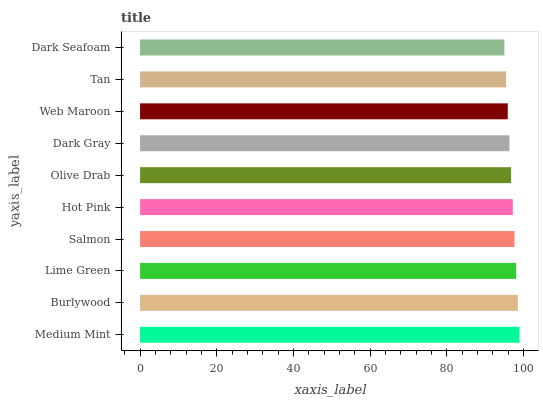Is Dark Seafoam the minimum?
Answer yes or no. Yes. Is Medium Mint the maximum?
Answer yes or no. Yes. Is Burlywood the minimum?
Answer yes or no. No. Is Burlywood the maximum?
Answer yes or no. No. Is Medium Mint greater than Burlywood?
Answer yes or no. Yes. Is Burlywood less than Medium Mint?
Answer yes or no. Yes. Is Burlywood greater than Medium Mint?
Answer yes or no. No. Is Medium Mint less than Burlywood?
Answer yes or no. No. Is Hot Pink the high median?
Answer yes or no. Yes. Is Olive Drab the low median?
Answer yes or no. Yes. Is Dark Gray the high median?
Answer yes or no. No. Is Dark Gray the low median?
Answer yes or no. No. 